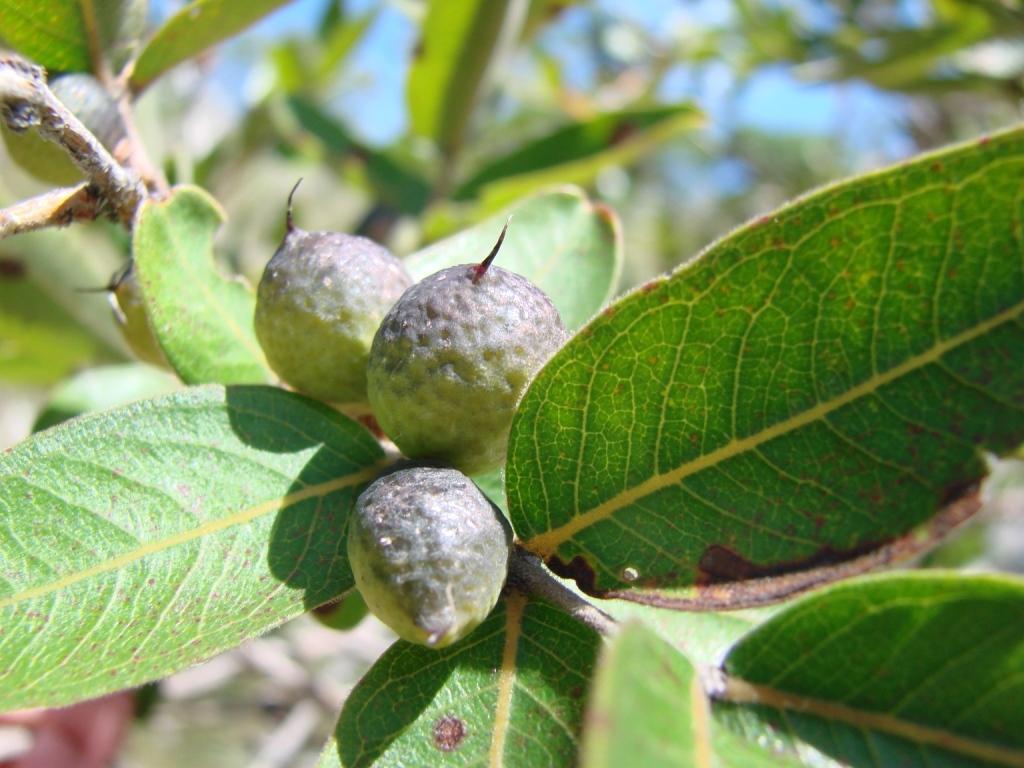How would you summarize this image in a sentence or two? In this picture we can observe fruits. There are green color leaves. The fruits are in grey color. In the background there is a sky. 